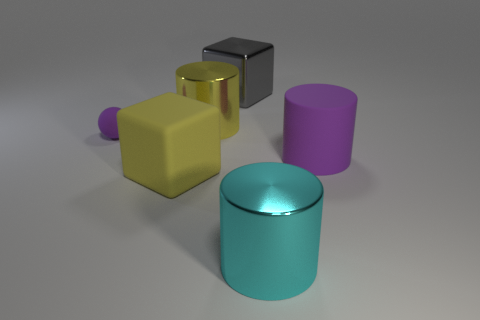Add 2 tiny rubber things. How many objects exist? 8 Subtract all purple cylinders. How many cylinders are left? 2 Subtract 3 cylinders. How many cylinders are left? 0 Subtract all gray cubes. How many cubes are left? 1 Subtract 0 blue cylinders. How many objects are left? 6 Subtract all blocks. How many objects are left? 4 Subtract all green blocks. Subtract all yellow cylinders. How many blocks are left? 2 Subtract all cyan cylinders. How many yellow cubes are left? 1 Subtract all matte spheres. Subtract all big purple rubber things. How many objects are left? 4 Add 2 cyan metallic objects. How many cyan metallic objects are left? 3 